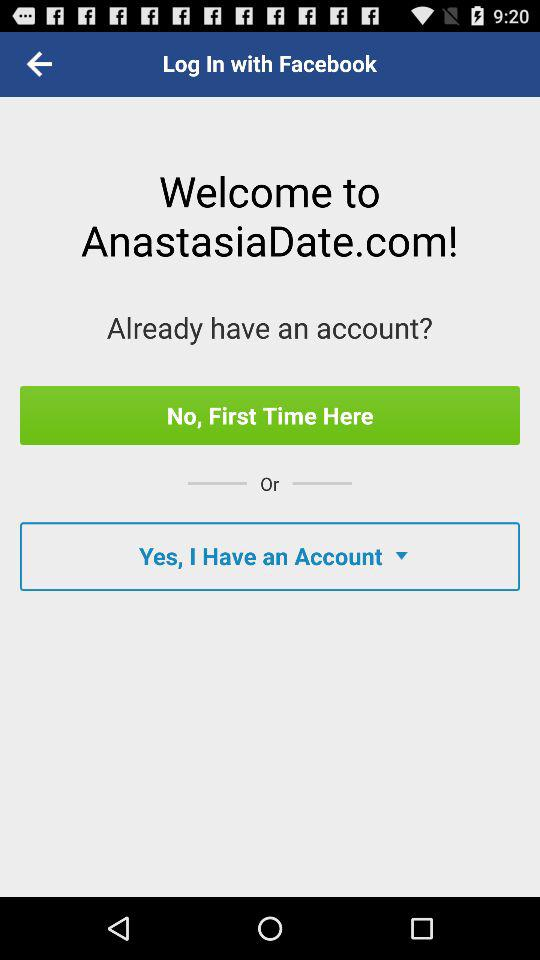What is the name of the application? The name of the application is "AnastasiaDate". 